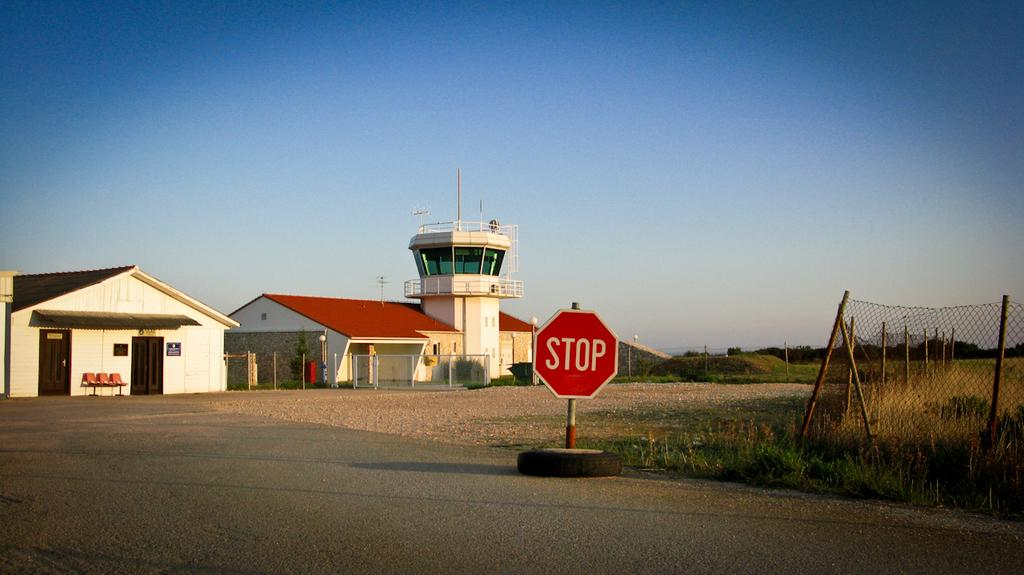What is the main object in the image? There is a sign board in the image. What else can be seen on the ground in the image? There is a tyre on the ground in the image. What type of structures are visible in the image? There are buildings visible in the image. What type of furniture is present in the image? Chairs are present in the image. What type of vegetation is visible in the image? Trees are visible in the image. What other objects can be seen in the image? There are other objects in the image, but their specific details are not mentioned in the provided facts. What is visible in the background of the image? The sky is visible in the background of the image. What type of celery is being used as a decoration on the chairs in the image? There is no celery present in the image; it is not mentioned in the provided facts. 